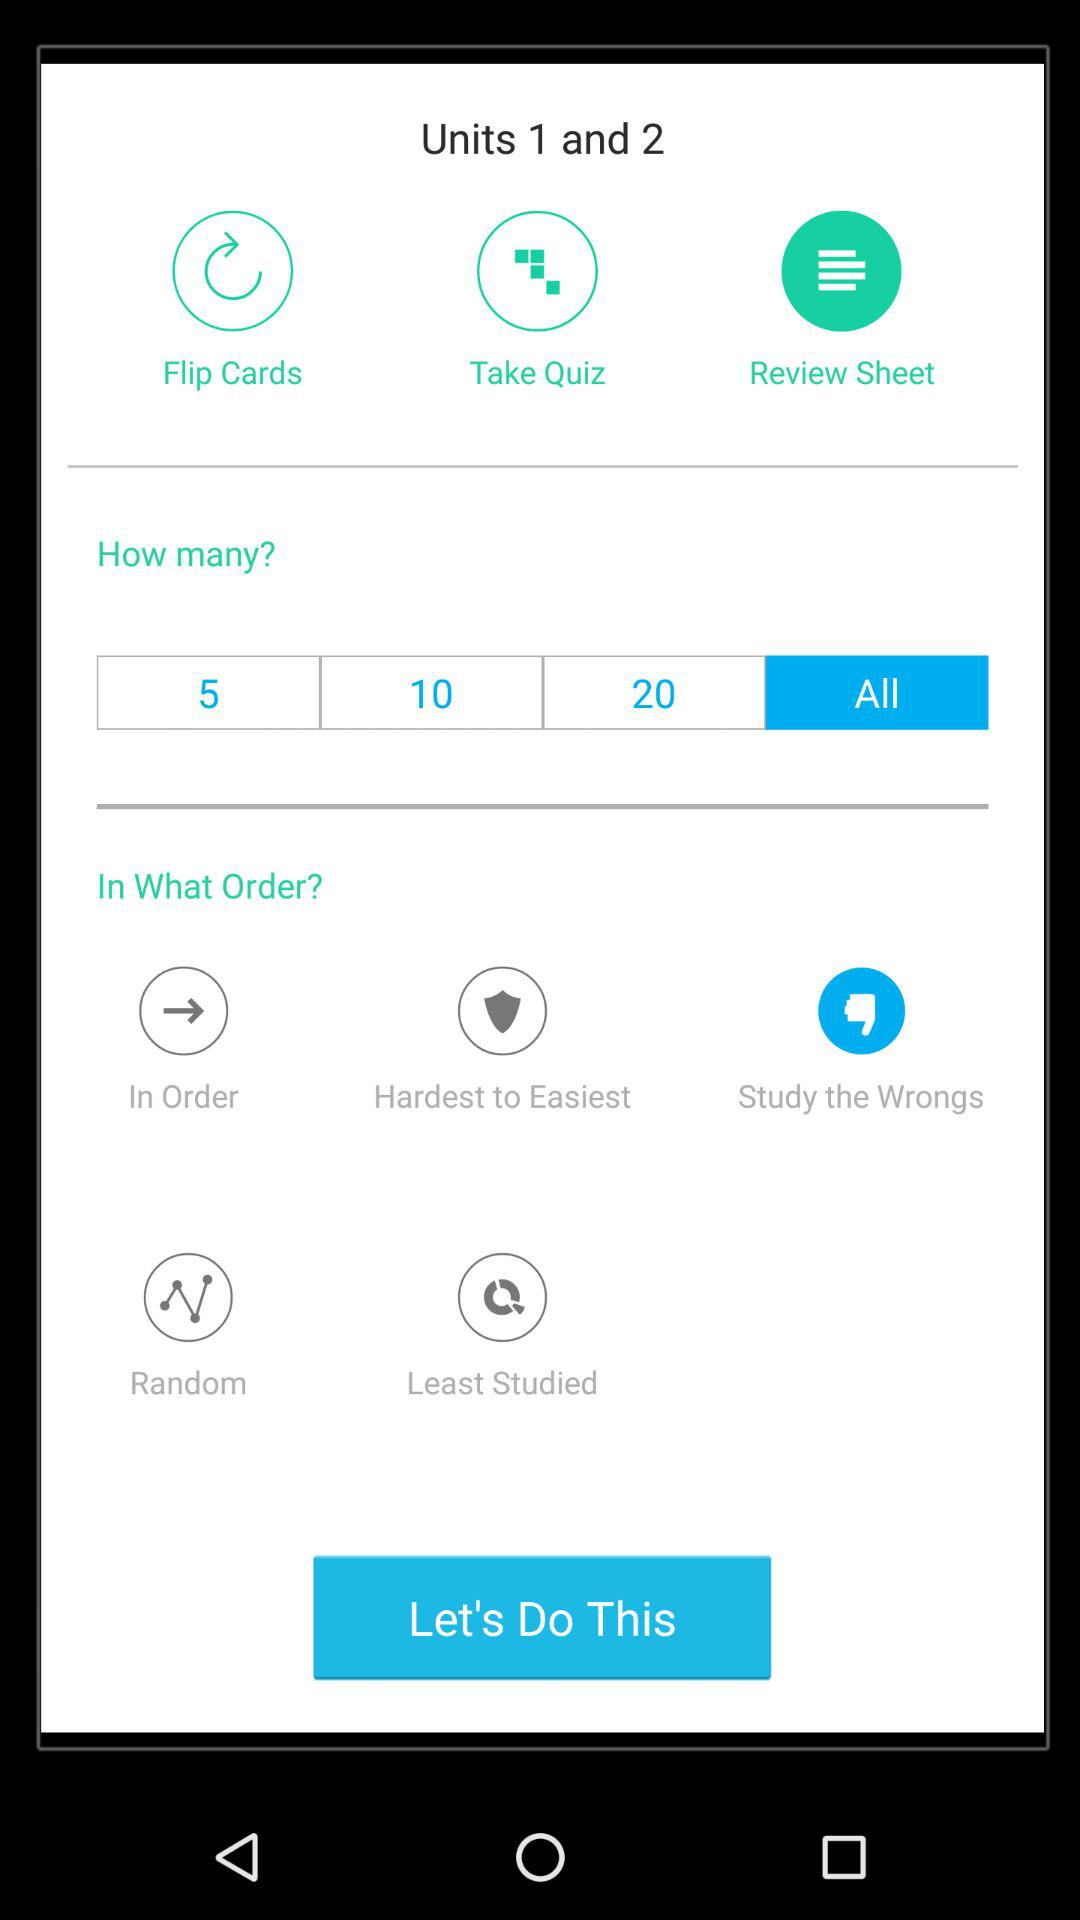What's the selected option in "Units 1 and 2"? The selected option is "Review Sheet". 